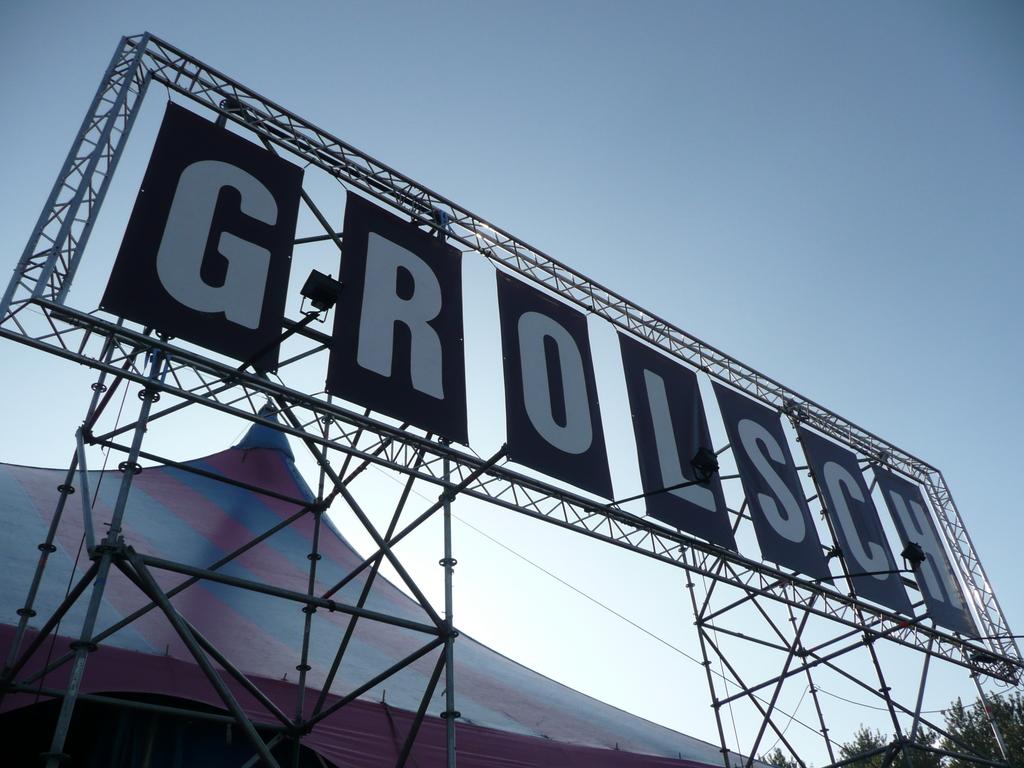What do the letters spell?
Your response must be concise. Grolsch. What word is displayed on the sign in white letters?
Offer a very short reply. Grolsch. 